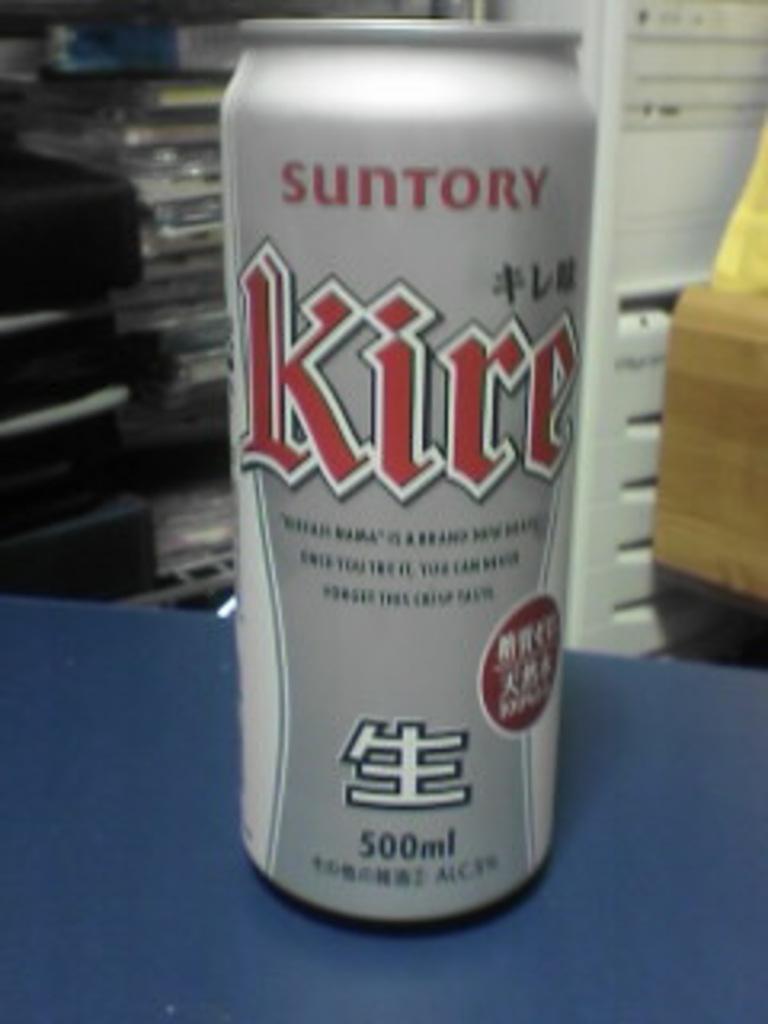What is the volume of the beverage?
Make the answer very short. 500ml. What is the brand of the drink?
Make the answer very short. Suntory. 